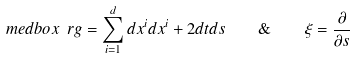Convert formula to latex. <formula><loc_0><loc_0><loc_500><loc_500>\ m e d b o x { \ r g = \sum _ { i = 1 } ^ { d } d x ^ { i } d x ^ { i } + 2 d t d s \quad \& \quad \xi = \frac { \partial } { \partial s } }</formula> 